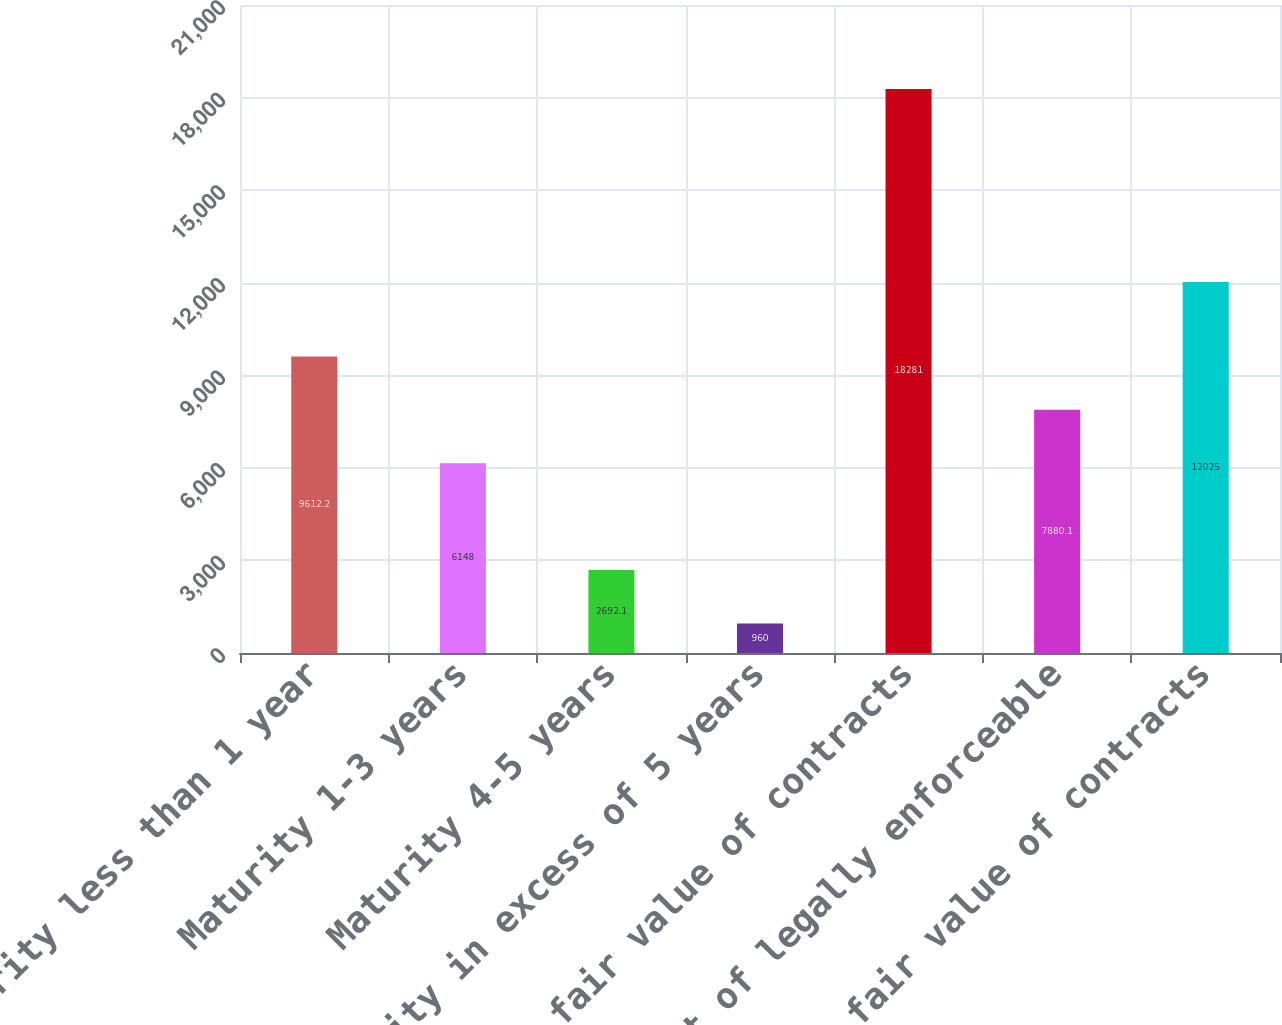Convert chart to OTSL. <chart><loc_0><loc_0><loc_500><loc_500><bar_chart><fcel>Maturity less than 1 year<fcel>Maturity 1-3 years<fcel>Maturity 4-5 years<fcel>Maturity in excess of 5 years<fcel>Gross fair value of contracts<fcel>Effect of legally enforceable<fcel>Net fair value of contracts<nl><fcel>9612.2<fcel>6148<fcel>2692.1<fcel>960<fcel>18281<fcel>7880.1<fcel>12025<nl></chart> 